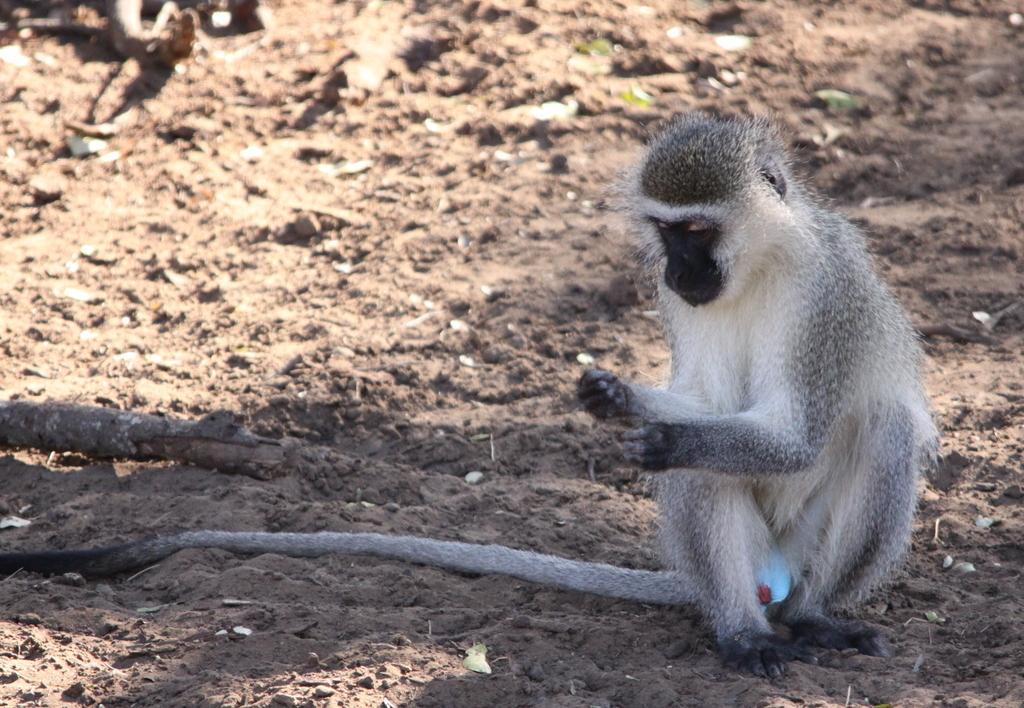Describe this image in one or two sentences. In front of the image there is a monkey. There are wooden poles. At the bottom of the image there is a sand. 